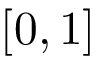Convert formula to latex. <formula><loc_0><loc_0><loc_500><loc_500>[ 0 , 1 ]</formula> 